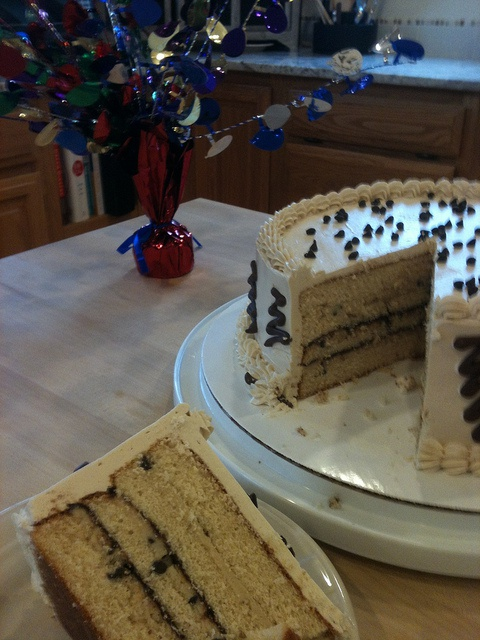Describe the objects in this image and their specific colors. I can see dining table in black, gray, olive, and darkgray tones, cake in black, gray, and darkgray tones, and cake in black and olive tones in this image. 